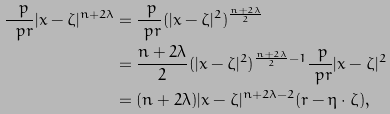Convert formula to latex. <formula><loc_0><loc_0><loc_500><loc_500>\frac { \ p } { \ p r } | x - \zeta | ^ { n + 2 \lambda } & = \frac { \ p } { \ p r } ( | x - \zeta | ^ { 2 } ) ^ { \frac { n + 2 \lambda } { 2 } } \\ & = \frac { n + 2 \lambda } { 2 } ( | x - \zeta | ^ { 2 } ) ^ { \frac { n + 2 \lambda } { 2 } - 1 } \frac { \ p } { \ p r } | x - \zeta | ^ { 2 } \\ & = ( n + 2 \lambda ) | x - \zeta | ^ { n + 2 \lambda - 2 } ( r - \eta \cdot \zeta ) ,</formula> 